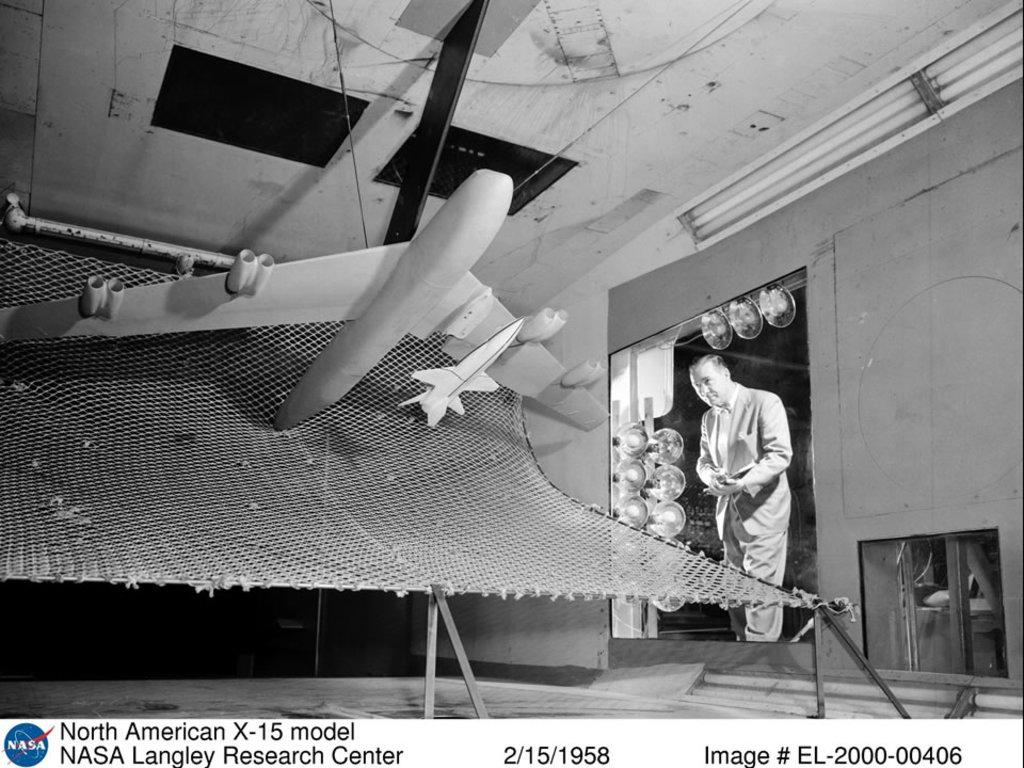<image>
Present a compact description of the photo's key features. A NASA display is a project from the Langley Research Center. 